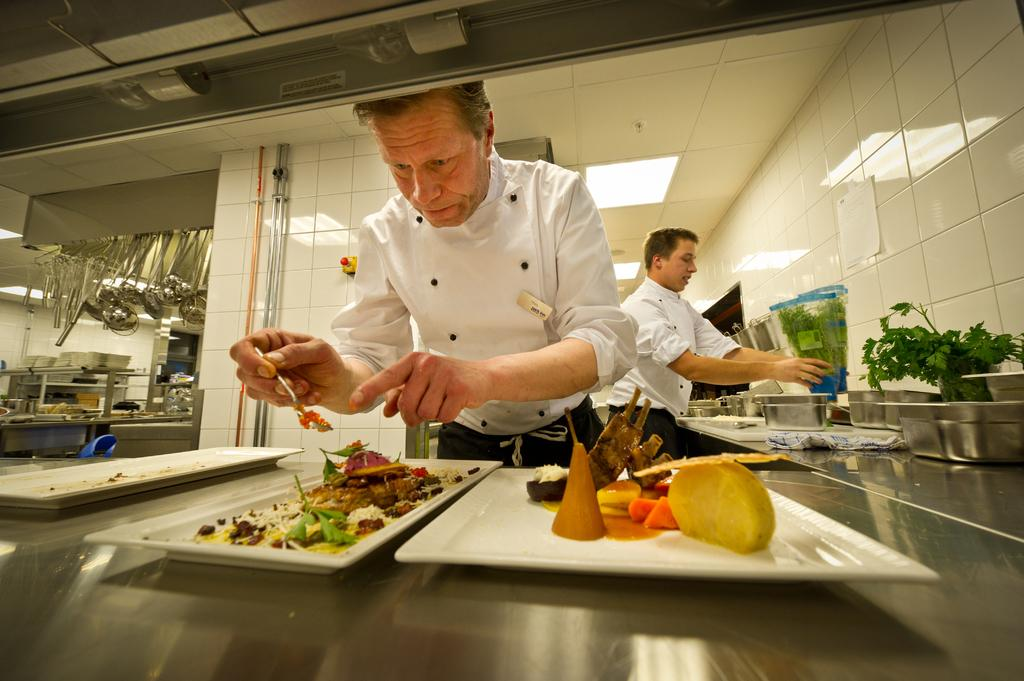How many people are present in the image? There are two men standing in the image. What object can be seen in the image that is typically used for holding or serving items? There is a white tray in the image. What is on the tray that the men might be serving or offering? There are food items on the tray. What can be seen in the background of the image? The walls are visible in the image. Can you describe the flock of butter that is flying around the men in the image? There is no flock of butter present in the image; it is not a realistic or logical scenario. 